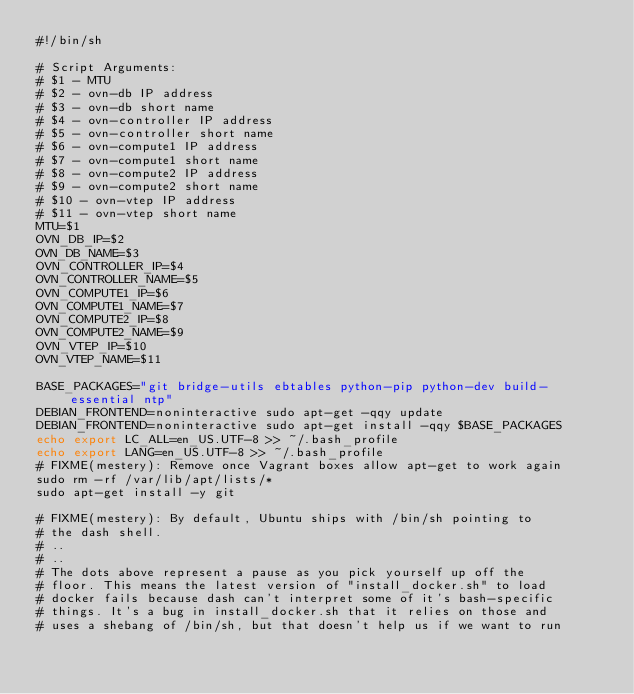<code> <loc_0><loc_0><loc_500><loc_500><_Bash_>#!/bin/sh

# Script Arguments:
# $1 - MTU
# $2 - ovn-db IP address
# $3 - ovn-db short name
# $4 - ovn-controller IP address
# $5 - ovn-controller short name
# $6 - ovn-compute1 IP address
# $7 - ovn-compute1 short name
# $8 - ovn-compute2 IP address
# $9 - ovn-compute2 short name
# $10 - ovn-vtep IP address
# $11 - ovn-vtep short name
MTU=$1
OVN_DB_IP=$2
OVN_DB_NAME=$3
OVN_CONTROLLER_IP=$4
OVN_CONTROLLER_NAME=$5
OVN_COMPUTE1_IP=$6
OVN_COMPUTE1_NAME=$7
OVN_COMPUTE2_IP=$8
OVN_COMPUTE2_NAME=$9
OVN_VTEP_IP=$10
OVN_VTEP_NAME=$11

BASE_PACKAGES="git bridge-utils ebtables python-pip python-dev build-essential ntp"
DEBIAN_FRONTEND=noninteractive sudo apt-get -qqy update
DEBIAN_FRONTEND=noninteractive sudo apt-get install -qqy $BASE_PACKAGES
echo export LC_ALL=en_US.UTF-8 >> ~/.bash_profile
echo export LANG=en_US.UTF-8 >> ~/.bash_profile
# FIXME(mestery): Remove once Vagrant boxes allow apt-get to work again
sudo rm -rf /var/lib/apt/lists/*
sudo apt-get install -y git

# FIXME(mestery): By default, Ubuntu ships with /bin/sh pointing to
# the dash shell.
# ..
# ..
# The dots above represent a pause as you pick yourself up off the
# floor. This means the latest version of "install_docker.sh" to load
# docker fails because dash can't interpret some of it's bash-specific
# things. It's a bug in install_docker.sh that it relies on those and
# uses a shebang of /bin/sh, but that doesn't help us if we want to run</code> 